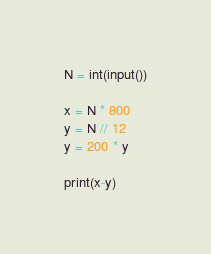<code> <loc_0><loc_0><loc_500><loc_500><_Python_>N = int(input())

x = N * 800
y = N // 12
y = 200 * y

print(x-y)</code> 